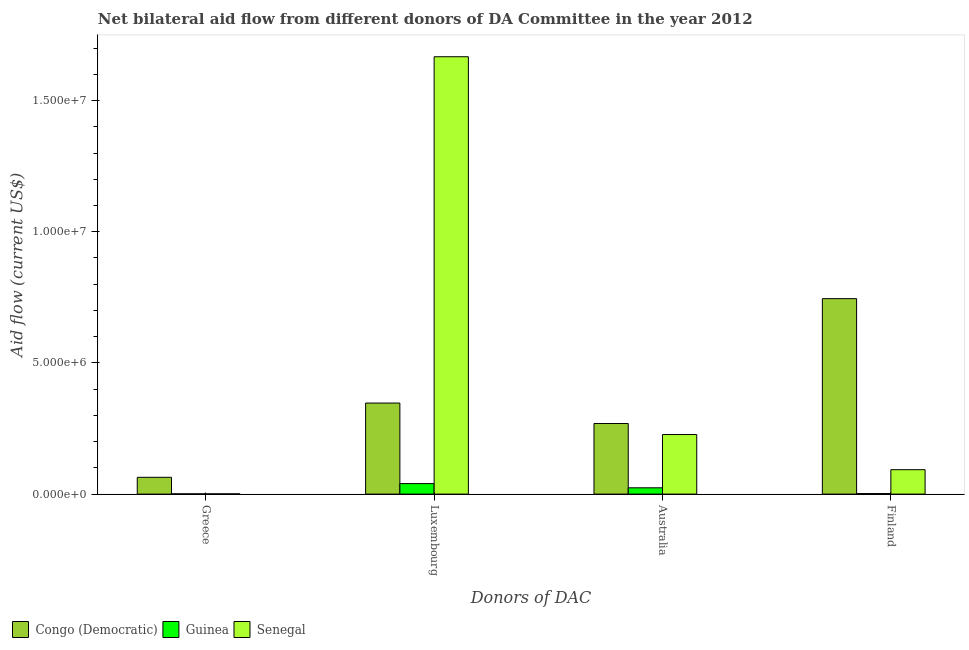How many different coloured bars are there?
Make the answer very short. 3. Are the number of bars per tick equal to the number of legend labels?
Your answer should be compact. Yes. Are the number of bars on each tick of the X-axis equal?
Your answer should be compact. Yes. How many bars are there on the 3rd tick from the left?
Provide a succinct answer. 3. What is the label of the 2nd group of bars from the left?
Your answer should be compact. Luxembourg. What is the amount of aid given by greece in Guinea?
Offer a terse response. 10000. Across all countries, what is the maximum amount of aid given by finland?
Make the answer very short. 7.45e+06. Across all countries, what is the minimum amount of aid given by greece?
Offer a very short reply. 10000. In which country was the amount of aid given by australia maximum?
Offer a very short reply. Congo (Democratic). In which country was the amount of aid given by greece minimum?
Offer a terse response. Guinea. What is the total amount of aid given by finland in the graph?
Offer a terse response. 8.40e+06. What is the difference between the amount of aid given by greece in Guinea and that in Senegal?
Your answer should be compact. 0. What is the difference between the amount of aid given by greece in Guinea and the amount of aid given by finland in Senegal?
Ensure brevity in your answer.  -9.20e+05. What is the average amount of aid given by luxembourg per country?
Your response must be concise. 6.85e+06. What is the difference between the amount of aid given by finland and amount of aid given by luxembourg in Congo (Democratic)?
Keep it short and to the point. 3.98e+06. In how many countries, is the amount of aid given by luxembourg greater than 14000000 US$?
Offer a very short reply. 1. What is the ratio of the amount of aid given by australia in Senegal to that in Guinea?
Offer a terse response. 9.46. Is the difference between the amount of aid given by finland in Congo (Democratic) and Senegal greater than the difference between the amount of aid given by greece in Congo (Democratic) and Senegal?
Provide a succinct answer. Yes. What is the difference between the highest and the second highest amount of aid given by luxembourg?
Give a very brief answer. 1.32e+07. What is the difference between the highest and the lowest amount of aid given by australia?
Make the answer very short. 2.45e+06. Is the sum of the amount of aid given by luxembourg in Congo (Democratic) and Senegal greater than the maximum amount of aid given by finland across all countries?
Make the answer very short. Yes. What does the 3rd bar from the left in Finland represents?
Provide a short and direct response. Senegal. What does the 2nd bar from the right in Greece represents?
Offer a very short reply. Guinea. How many bars are there?
Offer a terse response. 12. Are all the bars in the graph horizontal?
Give a very brief answer. No. How many countries are there in the graph?
Ensure brevity in your answer.  3. Does the graph contain any zero values?
Keep it short and to the point. No. How many legend labels are there?
Your answer should be very brief. 3. How are the legend labels stacked?
Your response must be concise. Horizontal. What is the title of the graph?
Your response must be concise. Net bilateral aid flow from different donors of DA Committee in the year 2012. Does "United Arab Emirates" appear as one of the legend labels in the graph?
Offer a terse response. No. What is the label or title of the X-axis?
Offer a very short reply. Donors of DAC. What is the Aid flow (current US$) of Congo (Democratic) in Greece?
Give a very brief answer. 6.40e+05. What is the Aid flow (current US$) in Senegal in Greece?
Make the answer very short. 10000. What is the Aid flow (current US$) in Congo (Democratic) in Luxembourg?
Keep it short and to the point. 3.47e+06. What is the Aid flow (current US$) in Senegal in Luxembourg?
Offer a very short reply. 1.67e+07. What is the Aid flow (current US$) of Congo (Democratic) in Australia?
Ensure brevity in your answer.  2.69e+06. What is the Aid flow (current US$) in Senegal in Australia?
Offer a terse response. 2.27e+06. What is the Aid flow (current US$) in Congo (Democratic) in Finland?
Ensure brevity in your answer.  7.45e+06. What is the Aid flow (current US$) of Senegal in Finland?
Give a very brief answer. 9.30e+05. Across all Donors of DAC, what is the maximum Aid flow (current US$) in Congo (Democratic)?
Offer a very short reply. 7.45e+06. Across all Donors of DAC, what is the maximum Aid flow (current US$) in Senegal?
Provide a succinct answer. 1.67e+07. Across all Donors of DAC, what is the minimum Aid flow (current US$) of Congo (Democratic)?
Your answer should be compact. 6.40e+05. Across all Donors of DAC, what is the minimum Aid flow (current US$) of Senegal?
Your answer should be very brief. 10000. What is the total Aid flow (current US$) in Congo (Democratic) in the graph?
Ensure brevity in your answer.  1.42e+07. What is the total Aid flow (current US$) of Guinea in the graph?
Give a very brief answer. 6.70e+05. What is the total Aid flow (current US$) in Senegal in the graph?
Ensure brevity in your answer.  1.99e+07. What is the difference between the Aid flow (current US$) of Congo (Democratic) in Greece and that in Luxembourg?
Your answer should be compact. -2.83e+06. What is the difference between the Aid flow (current US$) of Guinea in Greece and that in Luxembourg?
Your response must be concise. -3.90e+05. What is the difference between the Aid flow (current US$) in Senegal in Greece and that in Luxembourg?
Give a very brief answer. -1.67e+07. What is the difference between the Aid flow (current US$) in Congo (Democratic) in Greece and that in Australia?
Make the answer very short. -2.05e+06. What is the difference between the Aid flow (current US$) in Senegal in Greece and that in Australia?
Provide a short and direct response. -2.26e+06. What is the difference between the Aid flow (current US$) in Congo (Democratic) in Greece and that in Finland?
Ensure brevity in your answer.  -6.81e+06. What is the difference between the Aid flow (current US$) of Senegal in Greece and that in Finland?
Your answer should be compact. -9.20e+05. What is the difference between the Aid flow (current US$) in Congo (Democratic) in Luxembourg and that in Australia?
Offer a terse response. 7.80e+05. What is the difference between the Aid flow (current US$) of Guinea in Luxembourg and that in Australia?
Your answer should be very brief. 1.60e+05. What is the difference between the Aid flow (current US$) of Senegal in Luxembourg and that in Australia?
Offer a terse response. 1.44e+07. What is the difference between the Aid flow (current US$) in Congo (Democratic) in Luxembourg and that in Finland?
Make the answer very short. -3.98e+06. What is the difference between the Aid flow (current US$) of Guinea in Luxembourg and that in Finland?
Your response must be concise. 3.80e+05. What is the difference between the Aid flow (current US$) in Senegal in Luxembourg and that in Finland?
Your answer should be compact. 1.57e+07. What is the difference between the Aid flow (current US$) in Congo (Democratic) in Australia and that in Finland?
Keep it short and to the point. -4.76e+06. What is the difference between the Aid flow (current US$) of Senegal in Australia and that in Finland?
Give a very brief answer. 1.34e+06. What is the difference between the Aid flow (current US$) in Congo (Democratic) in Greece and the Aid flow (current US$) in Senegal in Luxembourg?
Your response must be concise. -1.60e+07. What is the difference between the Aid flow (current US$) in Guinea in Greece and the Aid flow (current US$) in Senegal in Luxembourg?
Offer a very short reply. -1.67e+07. What is the difference between the Aid flow (current US$) of Congo (Democratic) in Greece and the Aid flow (current US$) of Senegal in Australia?
Ensure brevity in your answer.  -1.63e+06. What is the difference between the Aid flow (current US$) in Guinea in Greece and the Aid flow (current US$) in Senegal in Australia?
Offer a terse response. -2.26e+06. What is the difference between the Aid flow (current US$) in Congo (Democratic) in Greece and the Aid flow (current US$) in Guinea in Finland?
Your response must be concise. 6.20e+05. What is the difference between the Aid flow (current US$) in Congo (Democratic) in Greece and the Aid flow (current US$) in Senegal in Finland?
Offer a very short reply. -2.90e+05. What is the difference between the Aid flow (current US$) in Guinea in Greece and the Aid flow (current US$) in Senegal in Finland?
Provide a succinct answer. -9.20e+05. What is the difference between the Aid flow (current US$) in Congo (Democratic) in Luxembourg and the Aid flow (current US$) in Guinea in Australia?
Your answer should be very brief. 3.23e+06. What is the difference between the Aid flow (current US$) of Congo (Democratic) in Luxembourg and the Aid flow (current US$) of Senegal in Australia?
Give a very brief answer. 1.20e+06. What is the difference between the Aid flow (current US$) of Guinea in Luxembourg and the Aid flow (current US$) of Senegal in Australia?
Offer a very short reply. -1.87e+06. What is the difference between the Aid flow (current US$) of Congo (Democratic) in Luxembourg and the Aid flow (current US$) of Guinea in Finland?
Offer a terse response. 3.45e+06. What is the difference between the Aid flow (current US$) in Congo (Democratic) in Luxembourg and the Aid flow (current US$) in Senegal in Finland?
Ensure brevity in your answer.  2.54e+06. What is the difference between the Aid flow (current US$) of Guinea in Luxembourg and the Aid flow (current US$) of Senegal in Finland?
Offer a terse response. -5.30e+05. What is the difference between the Aid flow (current US$) in Congo (Democratic) in Australia and the Aid flow (current US$) in Guinea in Finland?
Provide a succinct answer. 2.67e+06. What is the difference between the Aid flow (current US$) in Congo (Democratic) in Australia and the Aid flow (current US$) in Senegal in Finland?
Offer a terse response. 1.76e+06. What is the difference between the Aid flow (current US$) in Guinea in Australia and the Aid flow (current US$) in Senegal in Finland?
Make the answer very short. -6.90e+05. What is the average Aid flow (current US$) in Congo (Democratic) per Donors of DAC?
Keep it short and to the point. 3.56e+06. What is the average Aid flow (current US$) of Guinea per Donors of DAC?
Ensure brevity in your answer.  1.68e+05. What is the average Aid flow (current US$) in Senegal per Donors of DAC?
Give a very brief answer. 4.97e+06. What is the difference between the Aid flow (current US$) in Congo (Democratic) and Aid flow (current US$) in Guinea in Greece?
Provide a succinct answer. 6.30e+05. What is the difference between the Aid flow (current US$) of Congo (Democratic) and Aid flow (current US$) of Senegal in Greece?
Provide a succinct answer. 6.30e+05. What is the difference between the Aid flow (current US$) in Guinea and Aid flow (current US$) in Senegal in Greece?
Your answer should be very brief. 0. What is the difference between the Aid flow (current US$) in Congo (Democratic) and Aid flow (current US$) in Guinea in Luxembourg?
Your answer should be compact. 3.07e+06. What is the difference between the Aid flow (current US$) of Congo (Democratic) and Aid flow (current US$) of Senegal in Luxembourg?
Offer a terse response. -1.32e+07. What is the difference between the Aid flow (current US$) in Guinea and Aid flow (current US$) in Senegal in Luxembourg?
Make the answer very short. -1.63e+07. What is the difference between the Aid flow (current US$) in Congo (Democratic) and Aid flow (current US$) in Guinea in Australia?
Offer a terse response. 2.45e+06. What is the difference between the Aid flow (current US$) of Congo (Democratic) and Aid flow (current US$) of Senegal in Australia?
Ensure brevity in your answer.  4.20e+05. What is the difference between the Aid flow (current US$) of Guinea and Aid flow (current US$) of Senegal in Australia?
Your response must be concise. -2.03e+06. What is the difference between the Aid flow (current US$) of Congo (Democratic) and Aid flow (current US$) of Guinea in Finland?
Make the answer very short. 7.43e+06. What is the difference between the Aid flow (current US$) in Congo (Democratic) and Aid flow (current US$) in Senegal in Finland?
Your answer should be very brief. 6.52e+06. What is the difference between the Aid flow (current US$) of Guinea and Aid flow (current US$) of Senegal in Finland?
Provide a succinct answer. -9.10e+05. What is the ratio of the Aid flow (current US$) in Congo (Democratic) in Greece to that in Luxembourg?
Your response must be concise. 0.18. What is the ratio of the Aid flow (current US$) in Guinea in Greece to that in Luxembourg?
Offer a terse response. 0.03. What is the ratio of the Aid flow (current US$) of Senegal in Greece to that in Luxembourg?
Provide a succinct answer. 0. What is the ratio of the Aid flow (current US$) in Congo (Democratic) in Greece to that in Australia?
Your answer should be compact. 0.24. What is the ratio of the Aid flow (current US$) of Guinea in Greece to that in Australia?
Provide a succinct answer. 0.04. What is the ratio of the Aid flow (current US$) of Senegal in Greece to that in Australia?
Your response must be concise. 0. What is the ratio of the Aid flow (current US$) in Congo (Democratic) in Greece to that in Finland?
Give a very brief answer. 0.09. What is the ratio of the Aid flow (current US$) in Guinea in Greece to that in Finland?
Give a very brief answer. 0.5. What is the ratio of the Aid flow (current US$) of Senegal in Greece to that in Finland?
Keep it short and to the point. 0.01. What is the ratio of the Aid flow (current US$) in Congo (Democratic) in Luxembourg to that in Australia?
Offer a very short reply. 1.29. What is the ratio of the Aid flow (current US$) in Senegal in Luxembourg to that in Australia?
Offer a very short reply. 7.34. What is the ratio of the Aid flow (current US$) of Congo (Democratic) in Luxembourg to that in Finland?
Keep it short and to the point. 0.47. What is the ratio of the Aid flow (current US$) in Guinea in Luxembourg to that in Finland?
Your answer should be compact. 20. What is the ratio of the Aid flow (current US$) of Senegal in Luxembourg to that in Finland?
Your answer should be compact. 17.92. What is the ratio of the Aid flow (current US$) in Congo (Democratic) in Australia to that in Finland?
Give a very brief answer. 0.36. What is the ratio of the Aid flow (current US$) in Senegal in Australia to that in Finland?
Your answer should be compact. 2.44. What is the difference between the highest and the second highest Aid flow (current US$) of Congo (Democratic)?
Your response must be concise. 3.98e+06. What is the difference between the highest and the second highest Aid flow (current US$) in Guinea?
Your response must be concise. 1.60e+05. What is the difference between the highest and the second highest Aid flow (current US$) of Senegal?
Your answer should be very brief. 1.44e+07. What is the difference between the highest and the lowest Aid flow (current US$) in Congo (Democratic)?
Your answer should be very brief. 6.81e+06. What is the difference between the highest and the lowest Aid flow (current US$) of Senegal?
Offer a very short reply. 1.67e+07. 